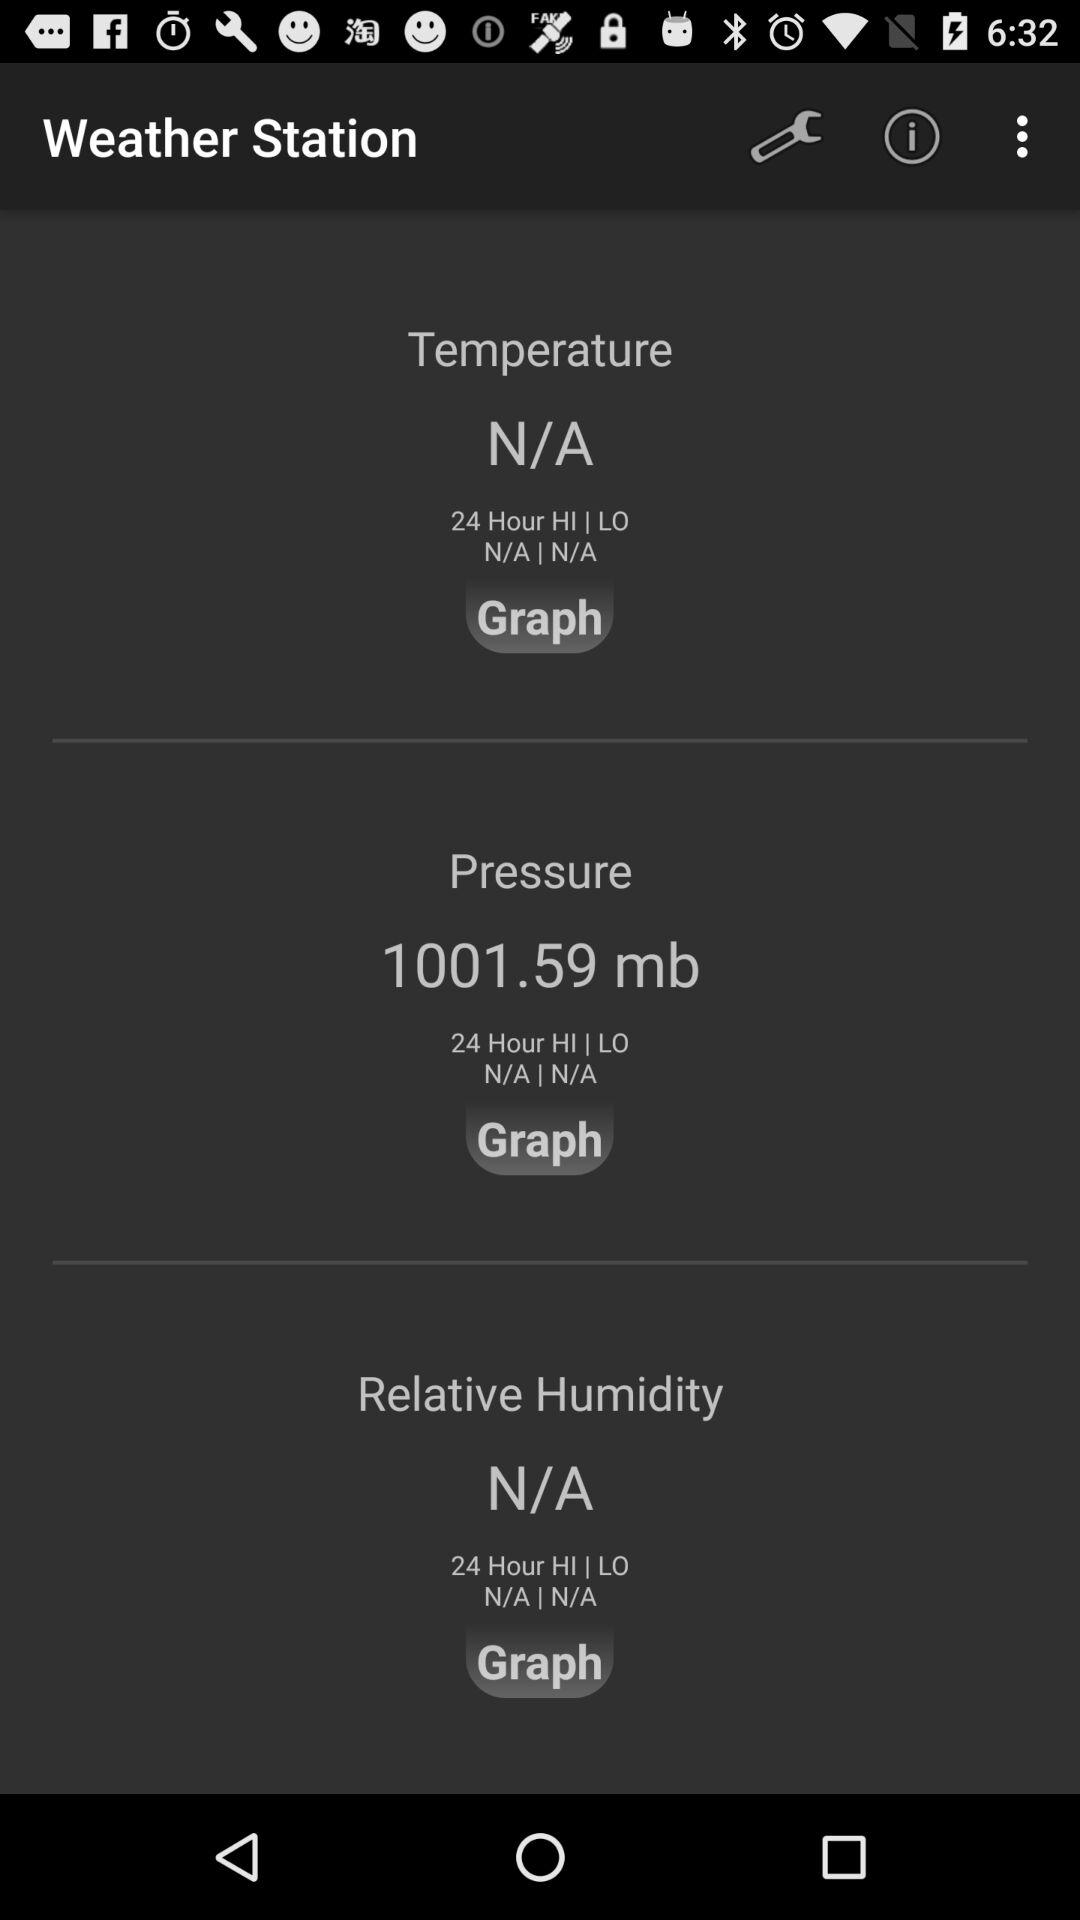What is the relative humidity? The relative humidity is not available. 